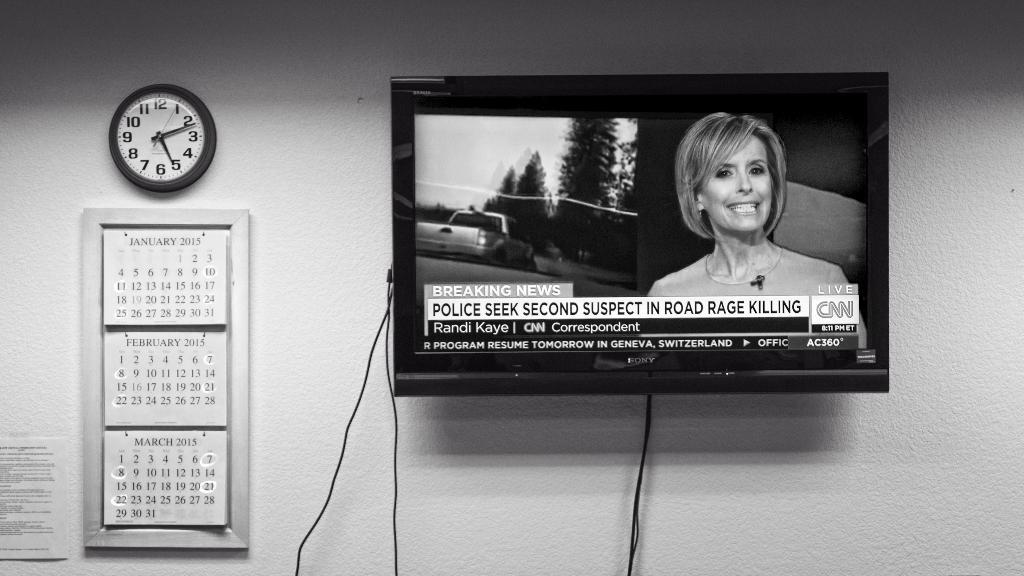How many suspects have the police found?
Make the answer very short. 1. What channel is this?
Offer a very short reply. Cnn. 